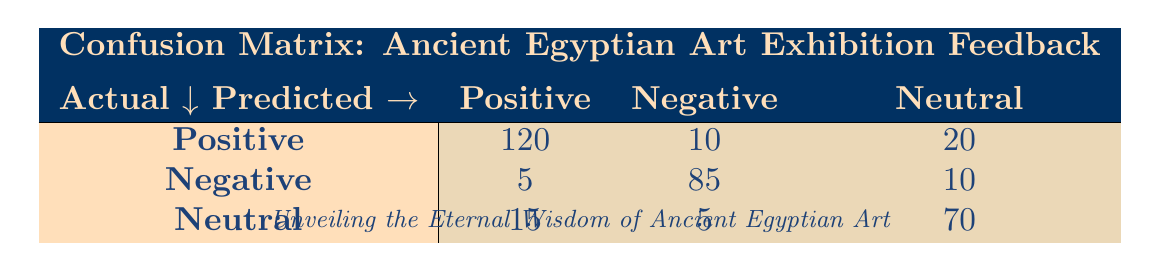What is the count of actual Positive feedback predicted as Positive? According to the table, there are 120 instances where the actual feedback was Positive and it was also predicted as Positive.
Answer: 120 What is the total number of Neutral predictions? To find the total count for Neutral predictions, we add up the counts in the Neutral column: 20 (from Positive) + 10 (from Negative) + 70 (from Neutral) = 100.
Answer: 100 How many instances of Negative feedback were predicted as Negative? The table shows 85 instances where the actual feedback was Negative, and it was predicted correctly as Negative.
Answer: 85 Is it true that more instances of Positive feedback were predicted as Neutral than Negative? To verify this, we compare the counts: Positive feedback predicted as Neutral is 20, and Positive predicted as Negative is 10. Since 20 is greater than 10, the statement is true.
Answer: Yes What is the average count of Neutral feedback across actual categories? For Neutral feedback, we have: 15 (from Positive) + 5 (from Negative) + 70 (from Neutral) = 90. Then, dividing by 3 (the number of actual categories), we get an average of 90/3 = 30.
Answer: 30 How many instances of Positive feedback were incorrectly predicted as Negative? The table indicates there are 10 instances of Positive feedback that were predicted as Negative, directly giving us that count.
Answer: 10 What is the total count of Negative feedback predicted incorrectly? To find this, we add the incorrect predictions for Negative feedback: 5 (predicted as Positive) + 10 (predicted as Neutral) = 15. Therefore, there are 15 instances of Negative feedback predicted incorrectly.
Answer: 15 How many more instances of Neutral feedback were correctly predicted compared to Negative feedback? Neutral feedback correctly predicted is 70, while Negative feedback correctly predicted is 85. The difference is calculated as 70 - 85 = -15, indicating there are 15 fewer Neutral instances correctly predicted.
Answer: -15 